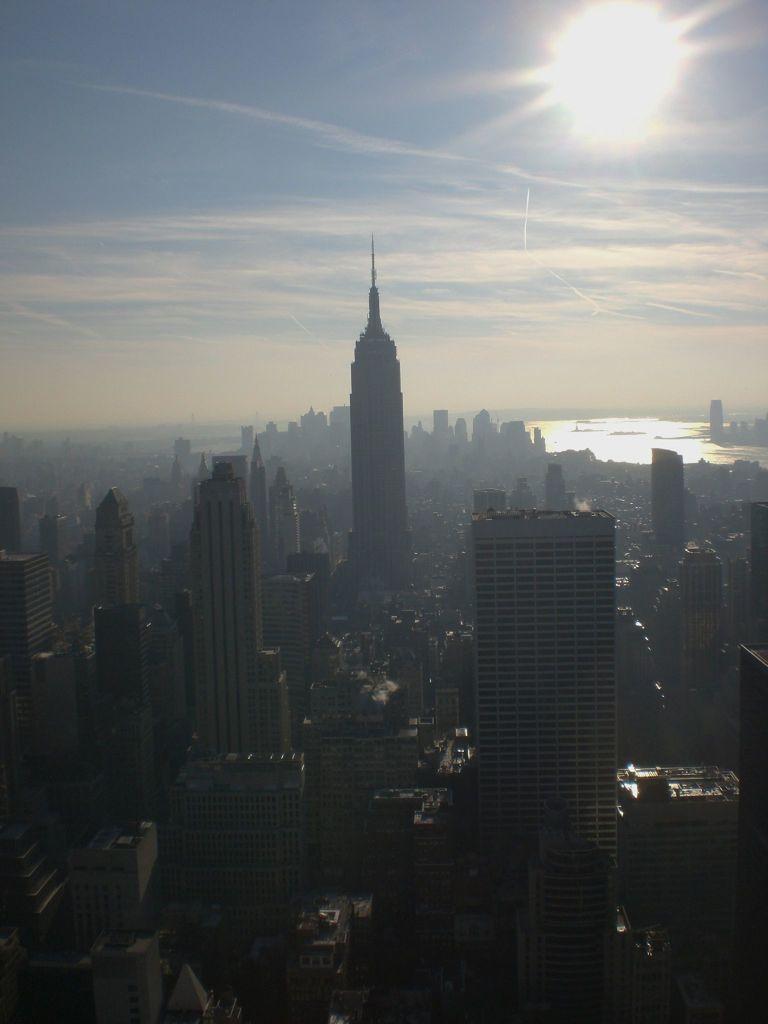How would you summarize this image in a sentence or two? In this picture I can see the city. In the city I can see the skyscrapers buildings and roads. on the right I can see the river. At the top I can see the sky, clouds and sun. 